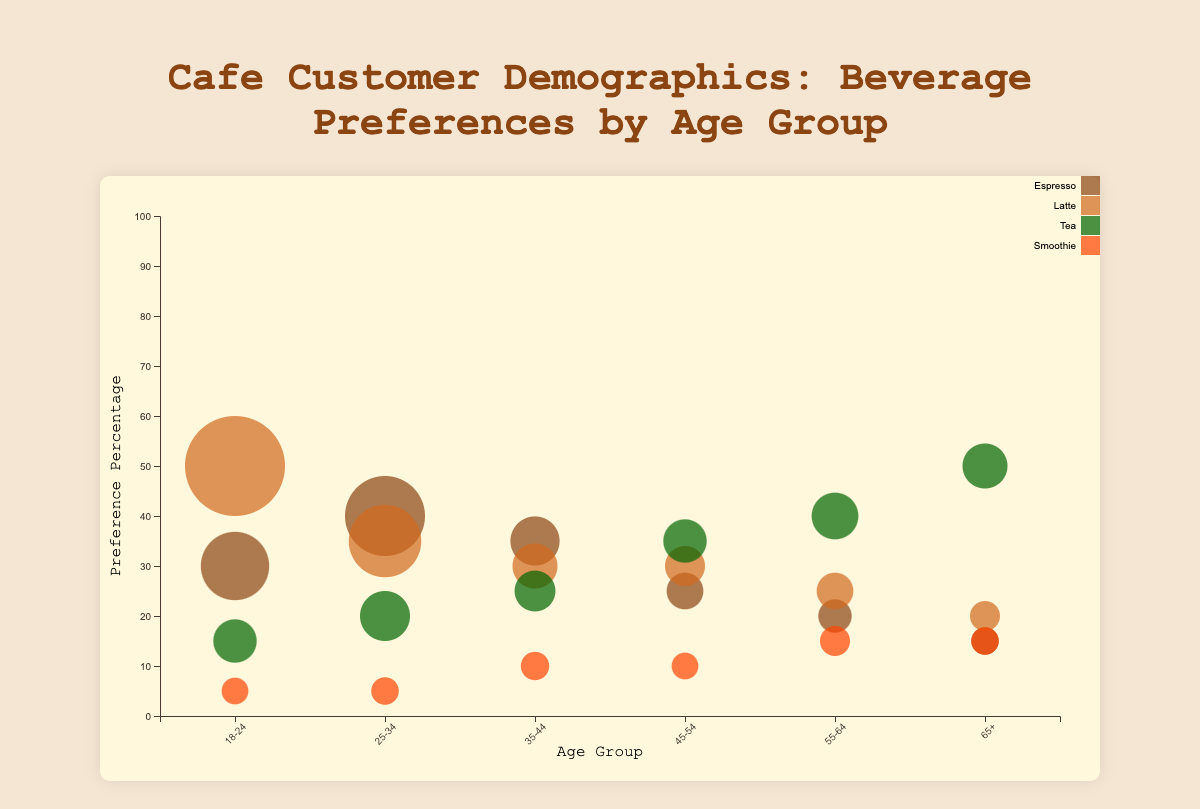What's the title of the chart? The title is displayed at the top of the chart, indicating what the bubble chart represents.
Answer: Cafe Customer Demographics: Beverage Preferences by Age Group Which age group prefers Latte the most? To determine this, look for the age group with the largest bubble for Latte. The 18-24 age group has the largest bubble, showing 50% preference.
Answer: 18-24 Among the 25-34 age group, which beverage is the least preferred? For the 25-34 age group, check the vertical position (percentage preference) of the smallest sized bubble. The Smoothie has the lowest position at 5%.
Answer: Smoothie How many age groups prefer Espresso more than 30%? Look at the Espresso bubbles and count how many are above the 30% mark on the y-axis. There are three such age groups: 18-24, 25-34, and 35-44.
Answer: 3 Which age group has the highest customer count for Tea? To find this, identify the largest bubble for Tea. The 65+ age group has the largest bubble with 300 customers.
Answer: 65+ What's the difference in percentage preference for Tea between age groups 45-54 and 55-64? The percentage preference for Tea in the 45-54 age group is 35%, and in the 55-64 age group, it is 40%. The difference is 40% - 35% = 5%.
Answer: 5% Compare the age groups 35-44 and 55-64 in terms of their preferences for Smoothie. Which one has a higher percentage preference? Check the vertical positions of the Smoothie bubbles for both age groups. The 55-64 age group has a 15% preference, which is higher than the 35-44 age group's 10%.
Answer: 55-64 What is the average percentage preference for Tea across all age groups? Add the percentage preferences for Tea (15, 20, 25, 35, 40, 50) and divide by the number of age groups (6). The calculation is (15 + 20 + 25 + 35 + 40 + 50) / 6 = 185 / 6 ≈ 30.83.
Answer: 30.83% Is there any age group where Tea is the most preferred beverage? Review each age group's bubble sizes and positions for Tea. The 65+ age group shows the highest preference for Tea at 50%.
Answer: Yes How does the preference for Latte change from age group 18-24 to 65+? Track the vertical positions (percentage) of Latte bubbles across the age groups from 18-24 to 65+. The preferences are: 50% (18-24), 35% (25-34), 30% (35-44), 30% (45-54), 25% (55-64), and 20% (65+).
Answer: Decreases 